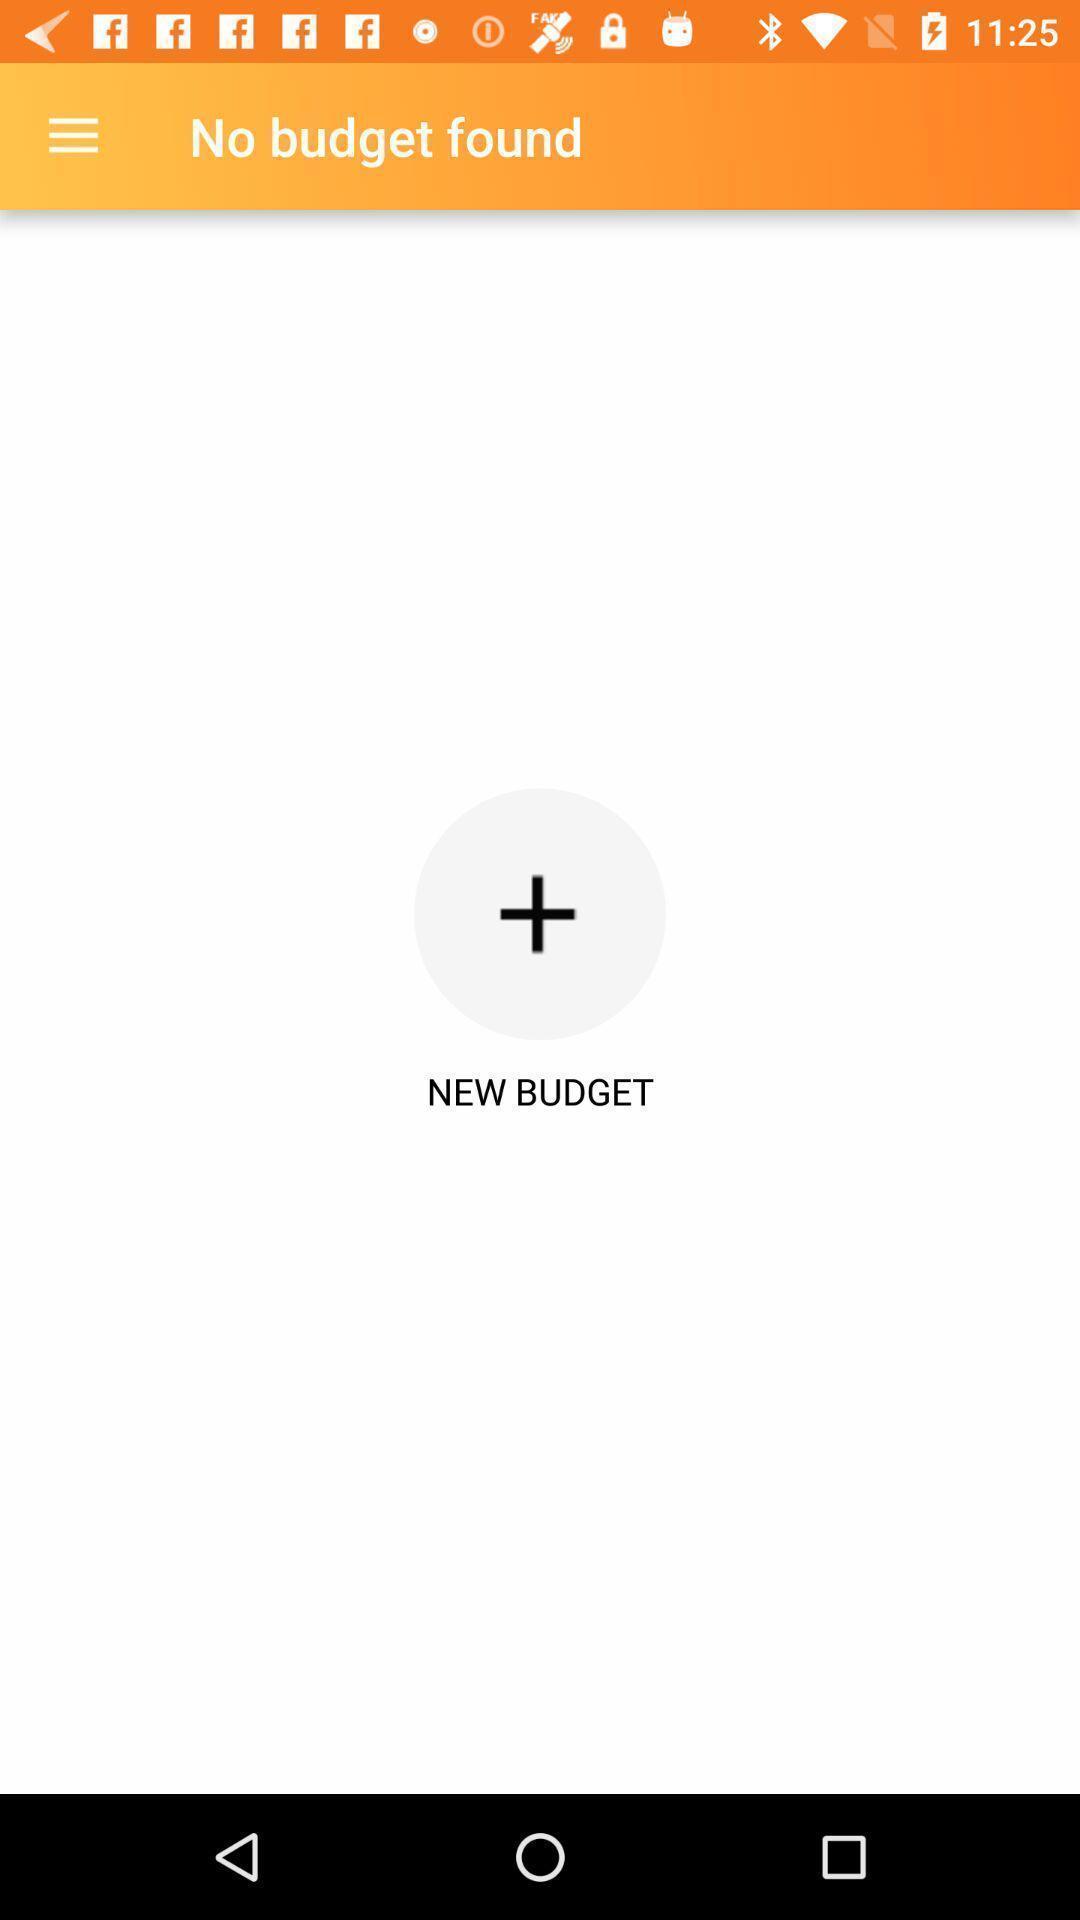Describe the content in this image. Page to add a budget. 